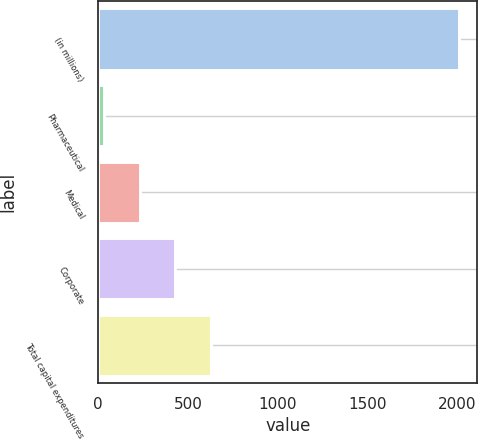<chart> <loc_0><loc_0><loc_500><loc_500><bar_chart><fcel>(in millions)<fcel>Pharmaceutical<fcel>Medical<fcel>Corporate<fcel>Total capital expenditures<nl><fcel>2010<fcel>33<fcel>230.7<fcel>428.4<fcel>626.1<nl></chart> 